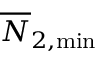<formula> <loc_0><loc_0><loc_500><loc_500>\overline { N } _ { 2 , \min }</formula> 